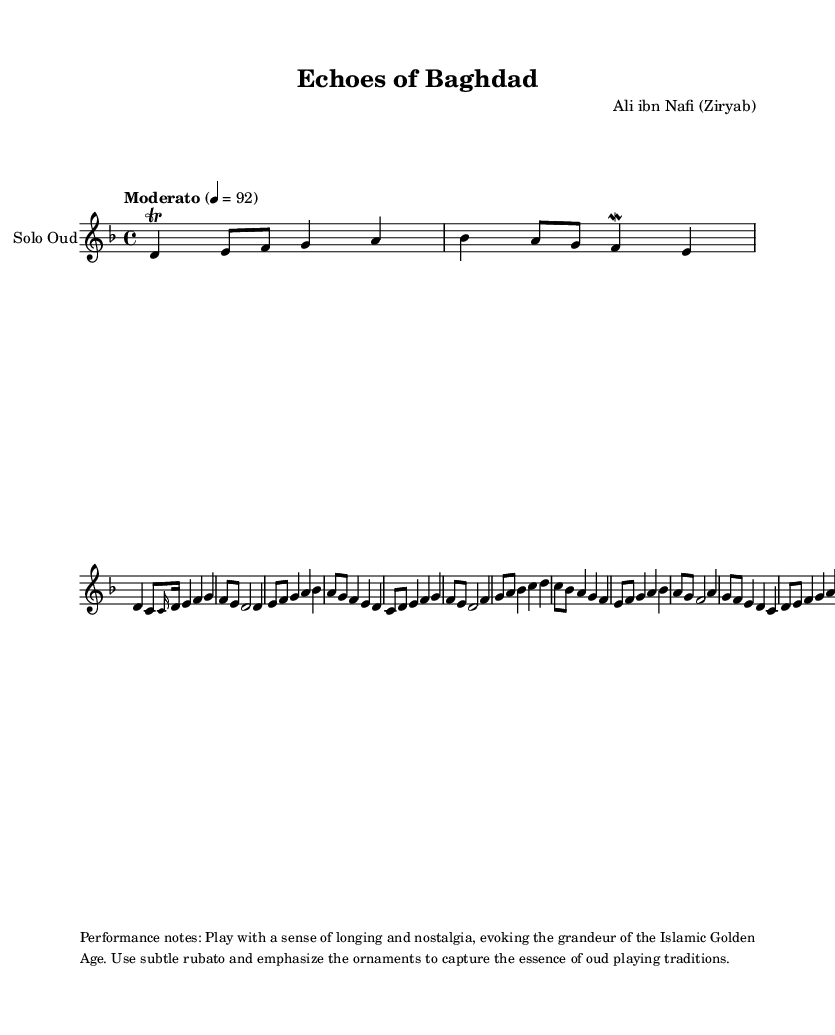What is the title of this composition? The title is found in the header section of the sheet music, where it states "Echoes of Baghdad."
Answer: Echoes of Baghdad What is the key signature of this music? The key signature is indicated by the symbol before the time signature. In this sheet music, it shows one flat, which corresponds to D minor.
Answer: D minor What is the time signature of this music? The time signature is located next to the key signature and is expressed as 4/4, meaning there are four beats in each measure.
Answer: 4/4 What is the tempo marking for this piece? The tempo marking is written above the staff, stating "Moderato" with a metronome marking of 92 beats per minute.
Answer: Moderato, 92 How many main themes are present in the composition? By analyzing the structure in the sheet music, the main theme appears twice, each time indicated clearly before the music notation.
Answer: 2 What is the dynamic mood suggested for the performance? Performance notes at the bottom indicate the mood; they suggest playing with a sense of longing and nostalgia, reflecting the essence of the Islamic Golden Age.
Answer: Longing and nostalgia Which instrument is the composition meant for? The instrumentation is specified at the start of the score, mentioning that this composition is specifically for "Solo Oud."
Answer: Solo Oud 